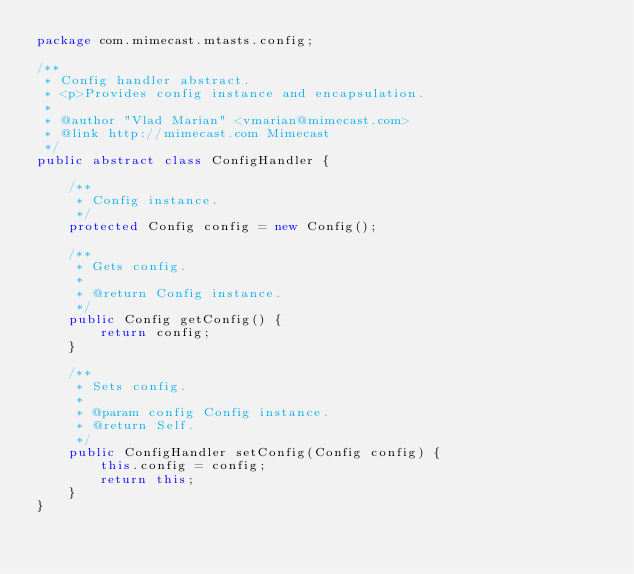<code> <loc_0><loc_0><loc_500><loc_500><_Java_>package com.mimecast.mtasts.config;

/**
 * Config handler abstract.
 * <p>Provides config instance and encapsulation.
 *
 * @author "Vlad Marian" <vmarian@mimecast.com>
 * @link http://mimecast.com Mimecast
 */
public abstract class ConfigHandler {

    /**
     * Config instance.
     */
    protected Config config = new Config();

    /**
     * Gets config.
     *
     * @return Config instance.
     */
    public Config getConfig() {
        return config;
    }

    /**
     * Sets config.
     *
     * @param config Config instance.
     * @return Self.
     */
    public ConfigHandler setConfig(Config config) {
        this.config = config;
        return this;
    }
}
</code> 